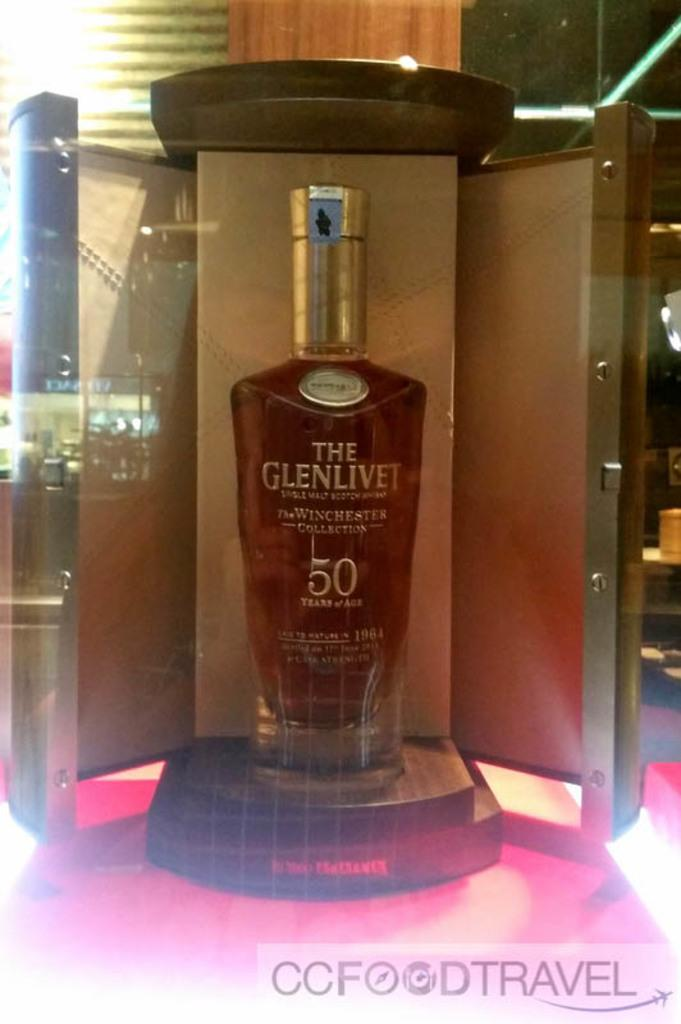What is the main object in the image? There is a wine bottle in the image. What can be seen at the bottom of the wine bottle? There is a watermark at the bottom of the wine bottle. Where is the light located in the image? The light is on the left side of the image. What type of shoe is being attacked by the wine bottle in the image? There is no shoe or attack present in the image; it only features a wine bottle with a watermark and a light on the left side. 